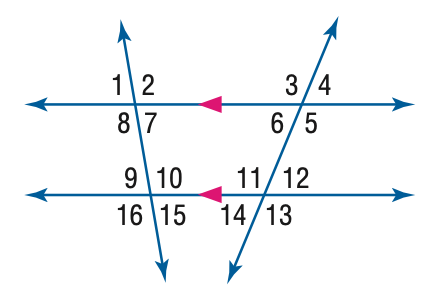Answer the mathemtical geometry problem and directly provide the correct option letter.
Question: In the figure, m \angle 8 = 96 and m \angle 12 = 42. Find the measure of \angle 6.
Choices: A: 42 B: 48 C: 84 D: 96 A 